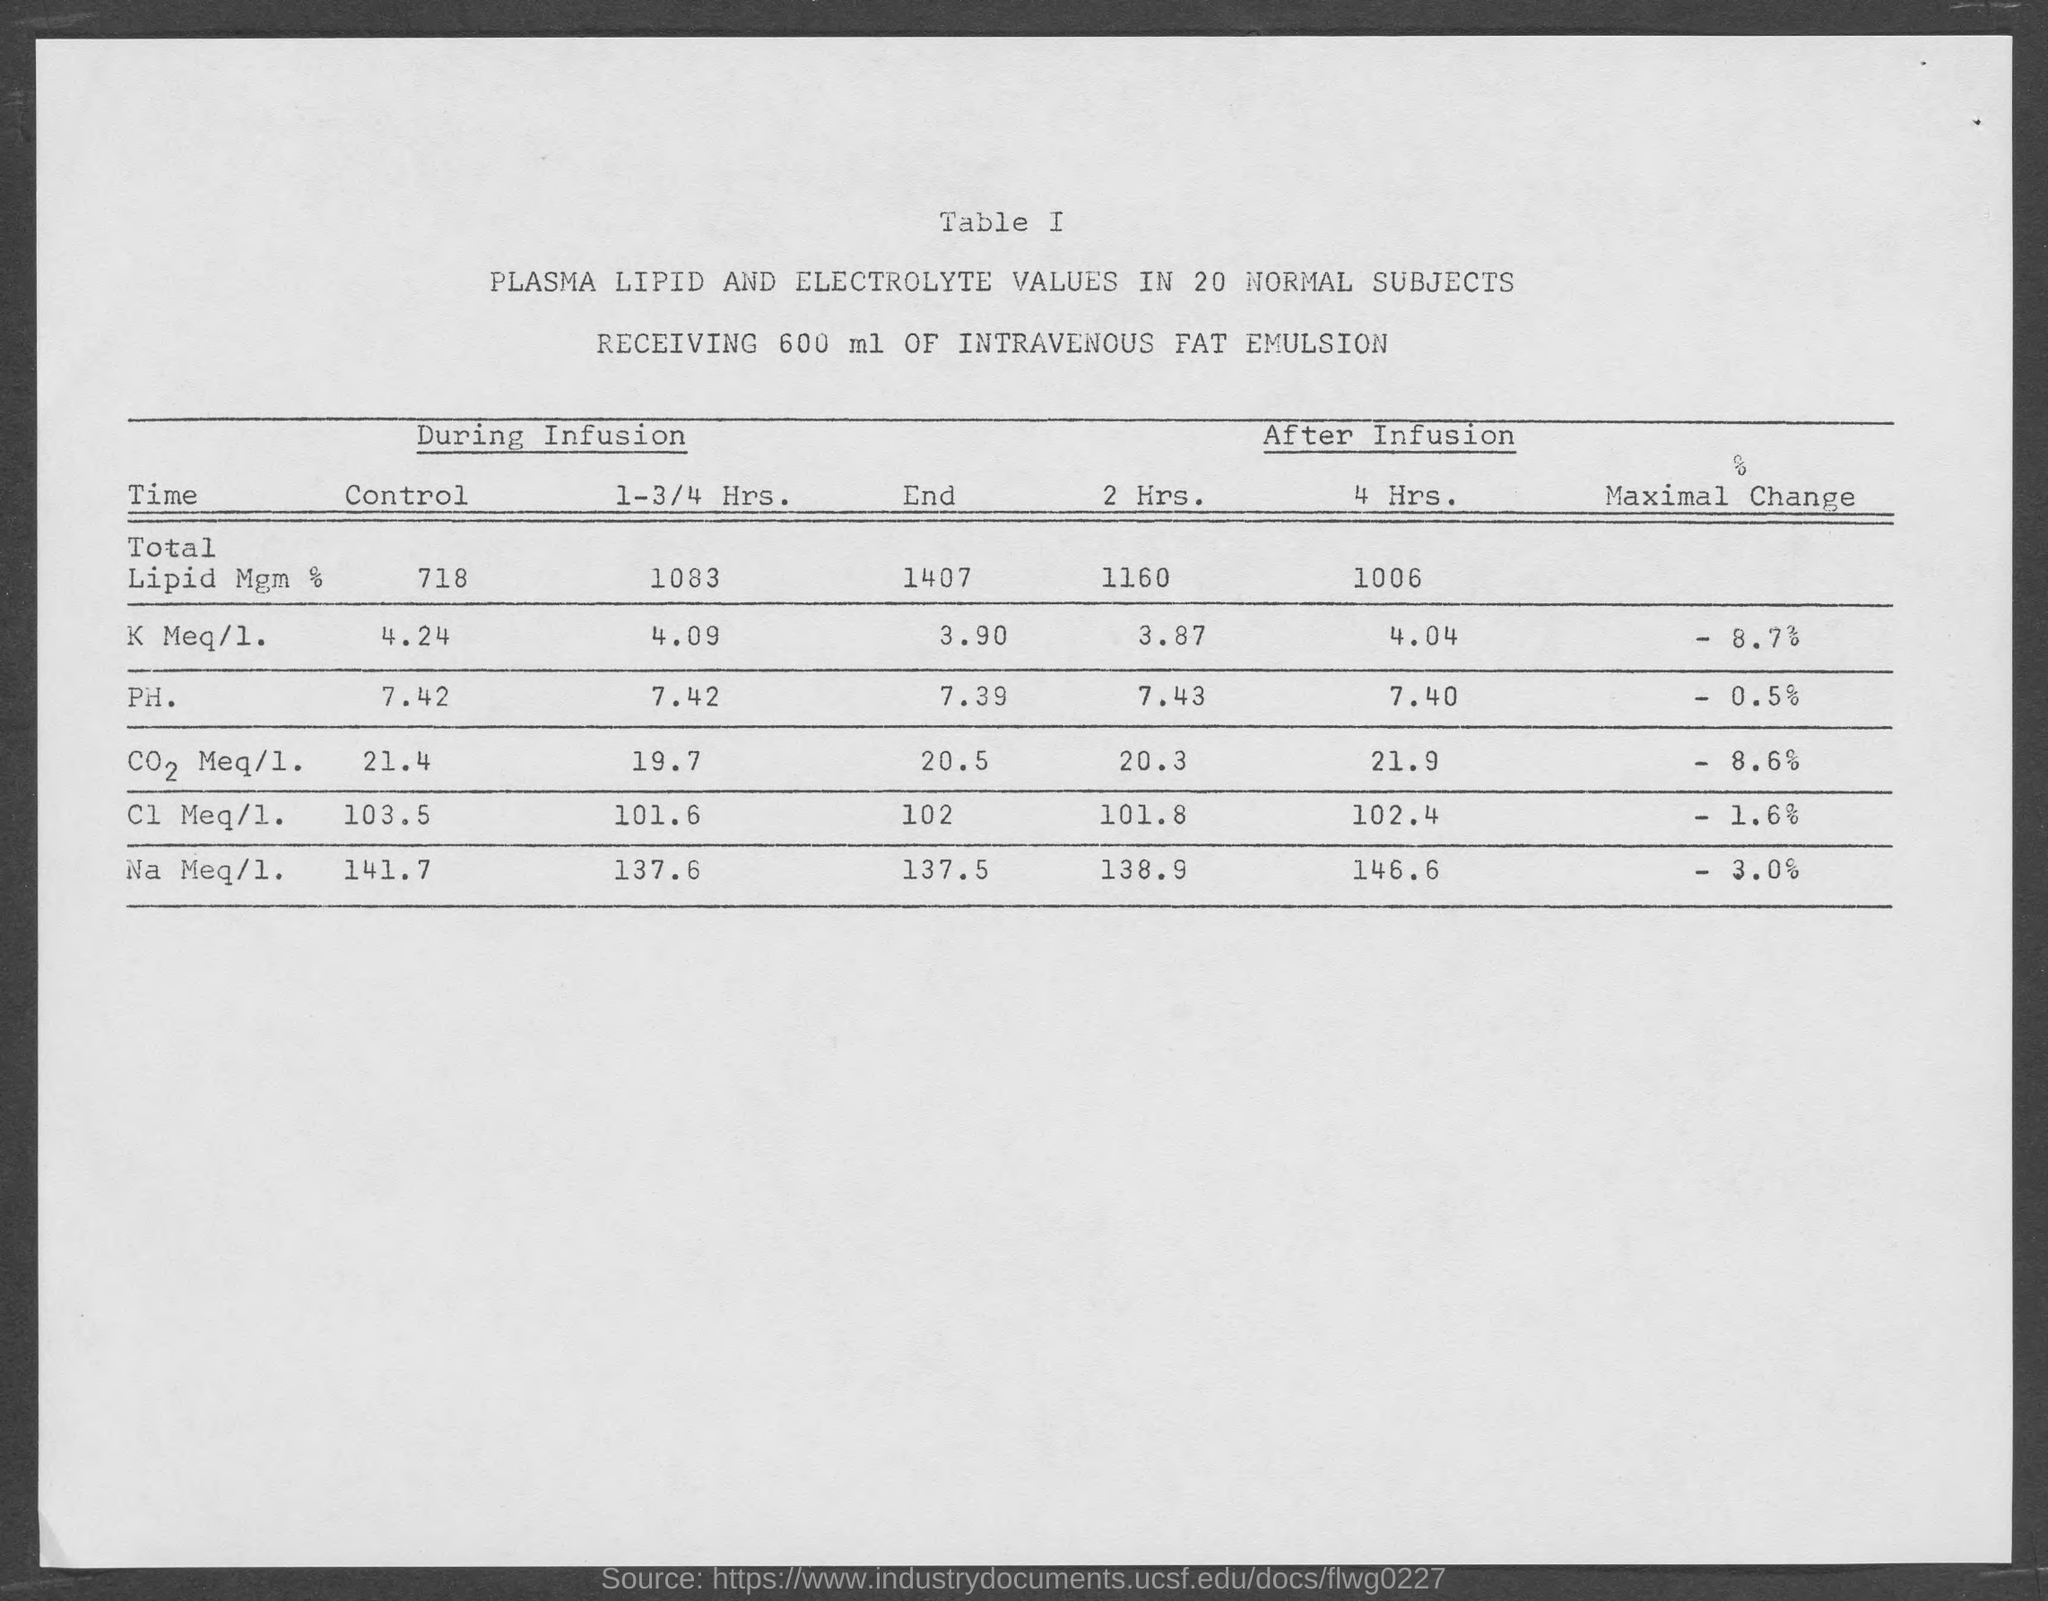Specify some key components in this picture. During infusion, the total lipid level was under control, achieving a value of 718. The patient received 600 milliliters of Intravenous Fat Emulsion. 